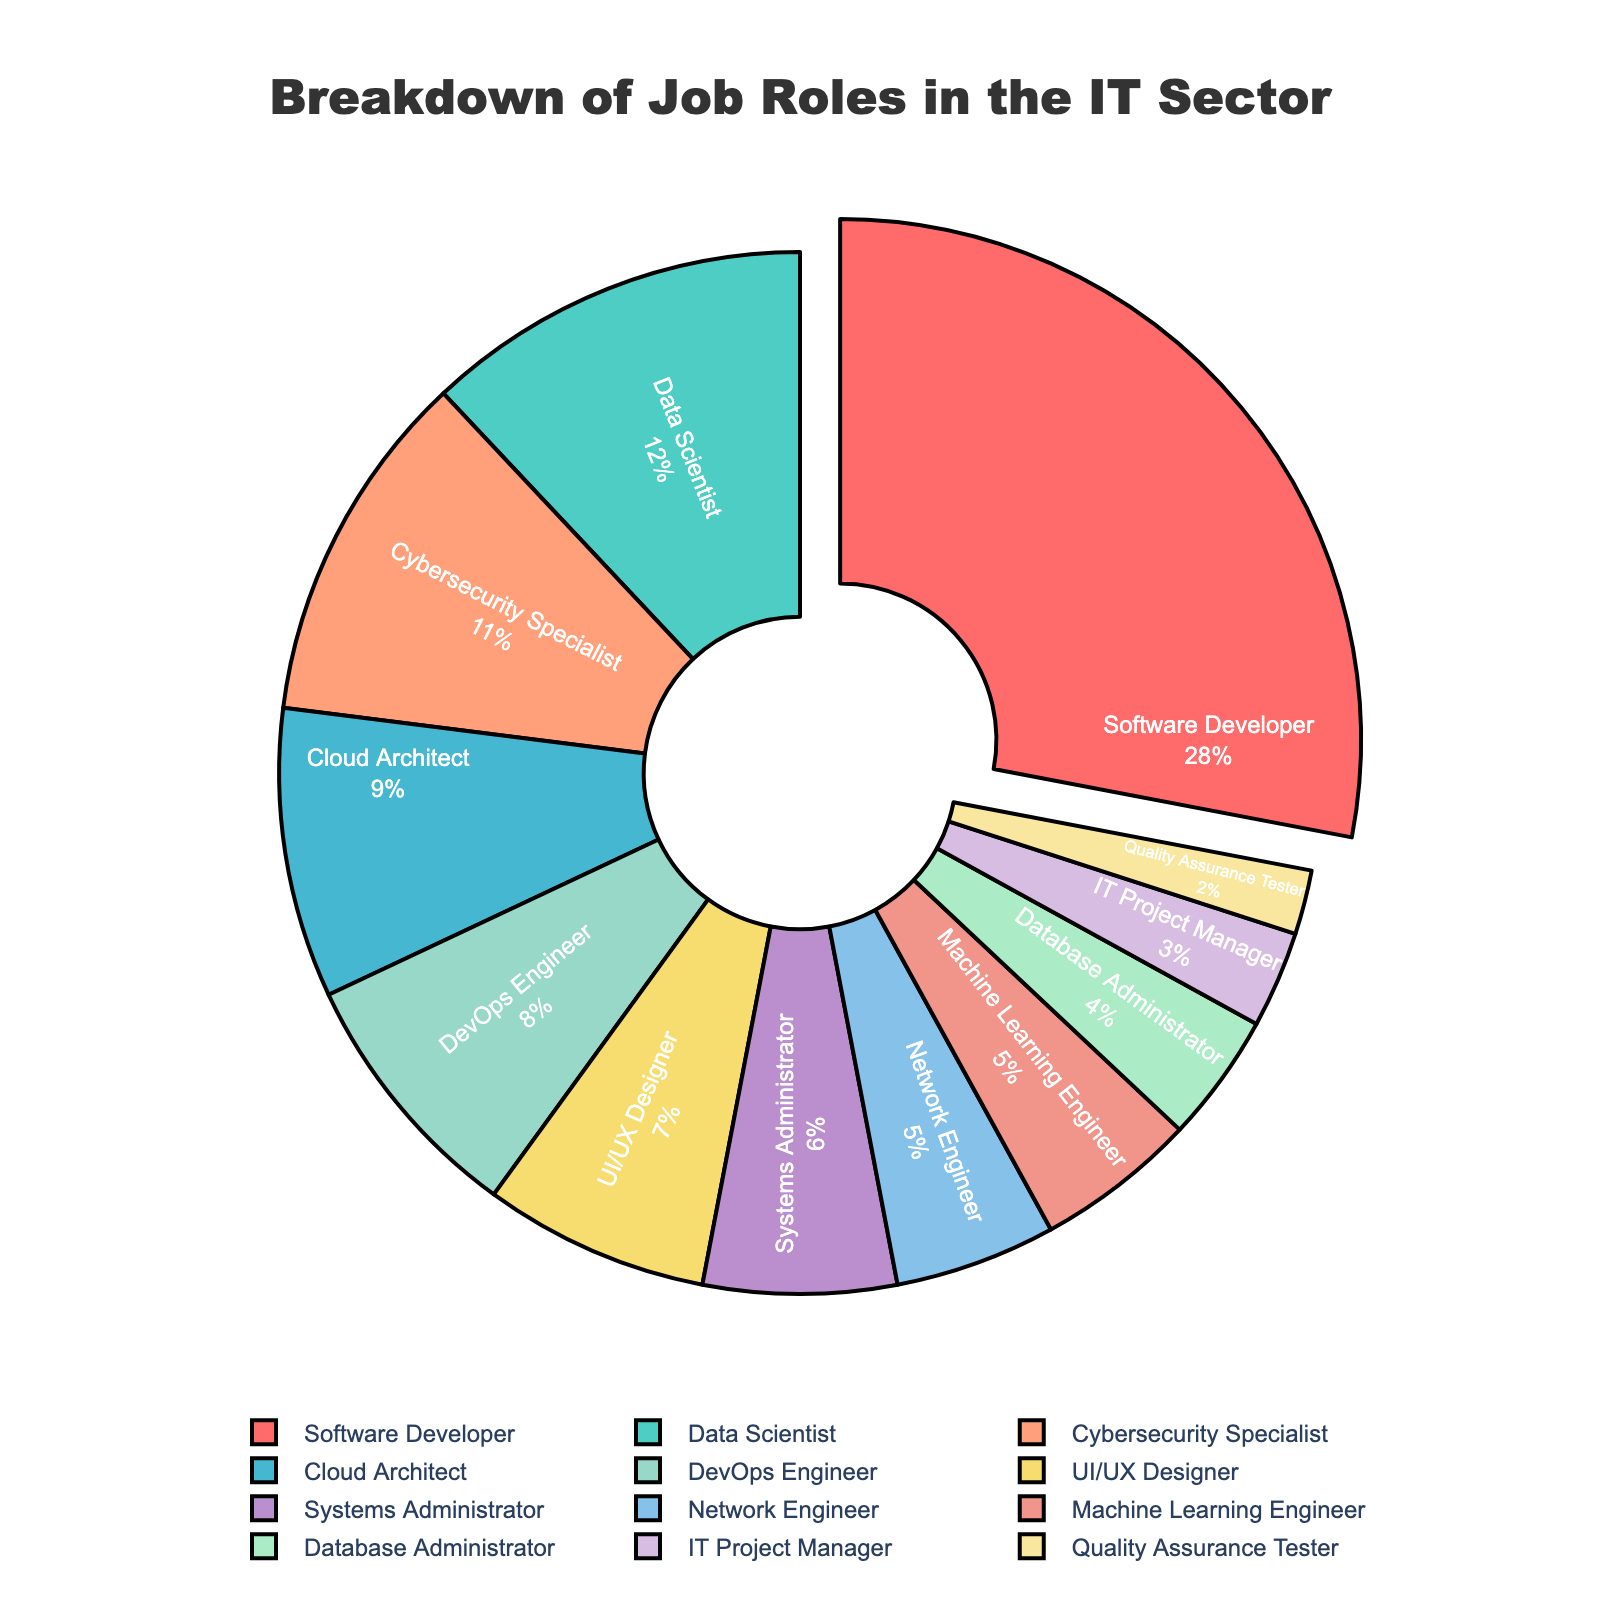Which job role has the highest percentage? The pie chart clearly highlights the largest section, which is labeled "Software Developer" with 28%.
Answer: Software Developer Which two roles combined make up the largest percentage after Software Developer? The second and third largest sections are Data Scientist (12%) and Cybersecurity Specialist (11%). Adding these together, we get 12% + 11% = 23%.
Answer: Data Scientist and Cybersecurity Specialist Which job role is represented by the red section of the pie chart? The red section of the pie chart corresponds to the largest slice pulled out, which is labeled "Software Developer."
Answer: Software Developer Is the proportion of Data Scientists greater than that of Systems Administrators? Comparing the label values, Data Scientists are 12% whereas Systems Administrators are 6%; hence, Data Scientists have a greater proportion.
Answer: Yes What is the total percentage formed by the roles Data Scientist, Cloud Architect, and Cybersecurity Specialist? The percentages are Data Scientist (12%), Cloud Architect (9%), and Cybersecurity Specialist (11%). Summing them up: 12% + 9% + 11% = 32%.
Answer: 32% Are there any job roles with a percentage less than or equal to 5%? The job roles with percentages less than or equal to 5% are Network Engineer (5%), Machine Learning Engineer (5%), Database Administrator (4%), IT Project Manager (3%), and Quality Assurance Tester (2%).
Answer: Yes What is the difference in percentage between DevOps Engineers and UI/UX Designers? DevOps Engineers have a percentage of 8% and UI/UX Designers have 7%. The difference is 8% - 7% = 1%.
Answer: 1% Which group has the smallest percentage? The smallest section labeled on the chart is "Quality Assurance Tester" which has 2%.
Answer: Quality Assurance Tester How many job roles have a percentage greater than 10%? The job roles with percentages greater than 10% are Software Developer (28%), Data Scientist (12%), and Cybersecurity Specialist (11%). Counting these, we get 3 roles.
Answer: 3 What is the average percentage for the roles Systems Administrator, Network Engineer, and Machine Learning Engineer? The percentages are Systems Administrator (6%), Network Engineer (5%), and Machine Learning Engineer (5%). Calculating the average: (6% + 5% + 5%) / 3 = 16% / 3 ≈ 5.33%.
Answer: 5.33% 